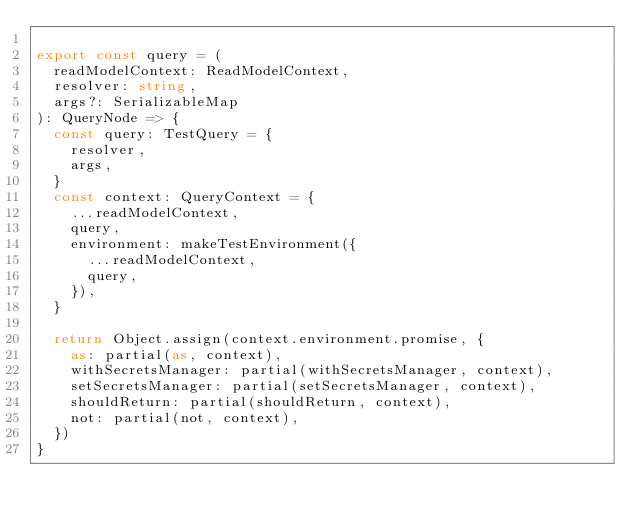Convert code to text. <code><loc_0><loc_0><loc_500><loc_500><_TypeScript_>
export const query = (
  readModelContext: ReadModelContext,
  resolver: string,
  args?: SerializableMap
): QueryNode => {
  const query: TestQuery = {
    resolver,
    args,
  }
  const context: QueryContext = {
    ...readModelContext,
    query,
    environment: makeTestEnvironment({
      ...readModelContext,
      query,
    }),
  }

  return Object.assign(context.environment.promise, {
    as: partial(as, context),
    withSecretsManager: partial(withSecretsManager, context),
    setSecretsManager: partial(setSecretsManager, context),
    shouldReturn: partial(shouldReturn, context),
    not: partial(not, context),
  })
}
</code> 